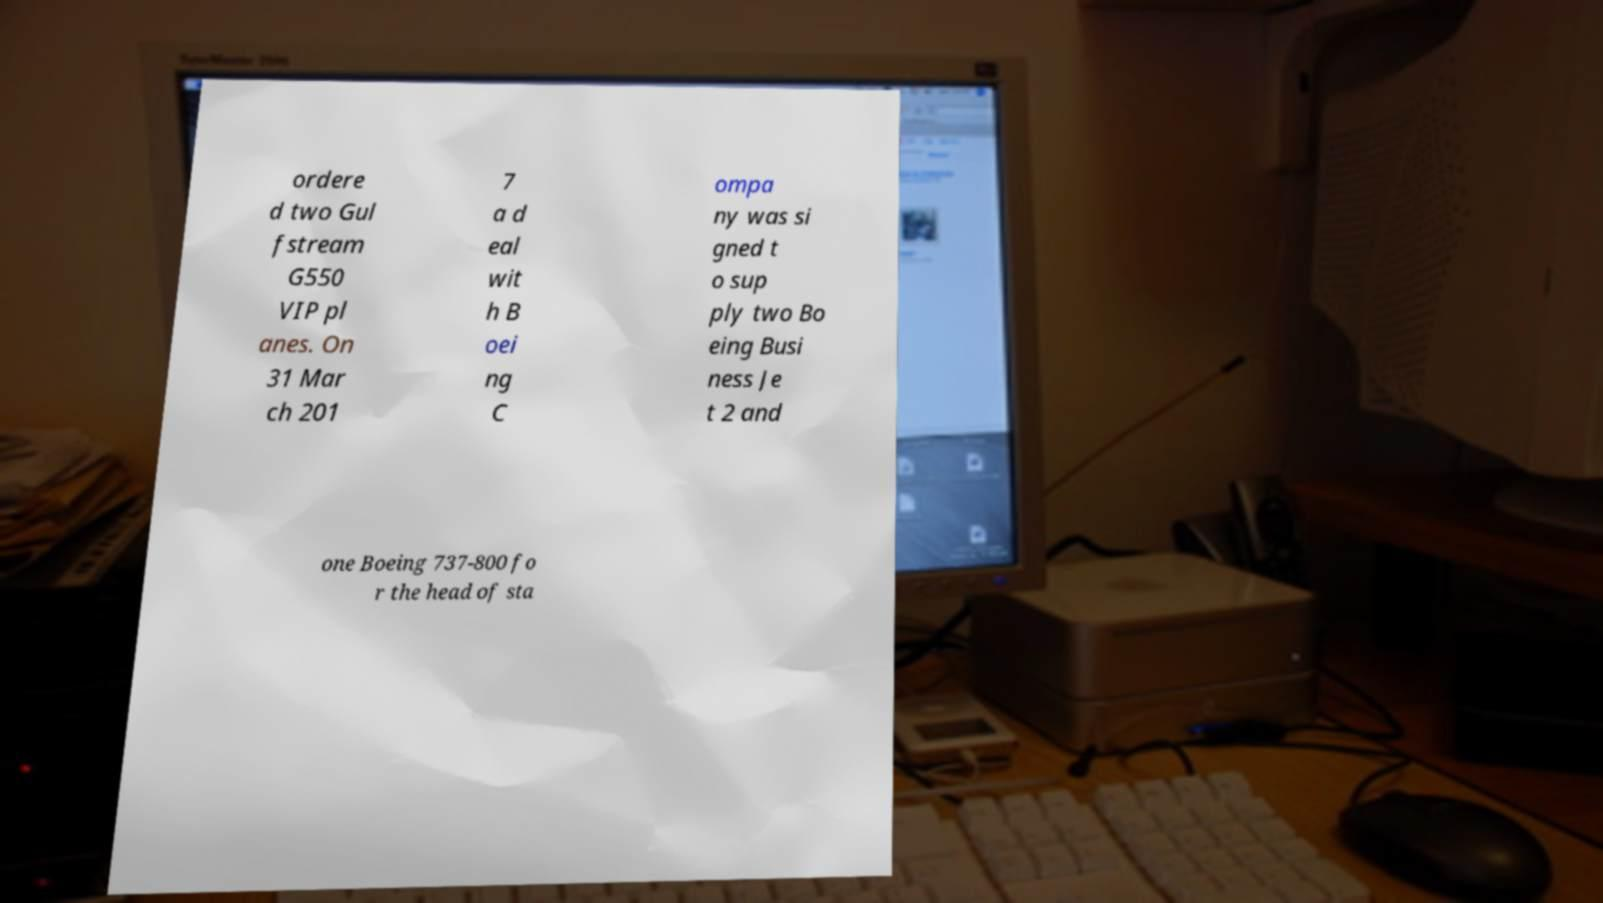Could you extract and type out the text from this image? ordere d two Gul fstream G550 VIP pl anes. On 31 Mar ch 201 7 a d eal wit h B oei ng C ompa ny was si gned t o sup ply two Bo eing Busi ness Je t 2 and one Boeing 737-800 fo r the head of sta 